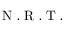Convert formula to latex. <formula><loc_0><loc_0><loc_500><loc_500>N . R . T .</formula> 